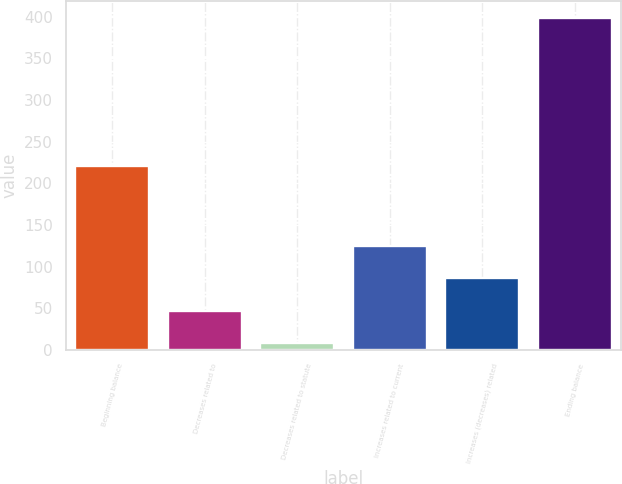Convert chart. <chart><loc_0><loc_0><loc_500><loc_500><bar_chart><fcel>Beginning balance<fcel>Decreases related to<fcel>Decreases related to statute<fcel>Increases related to current<fcel>Increases (decreases) related<fcel>Ending balance<nl><fcel>220.7<fcel>46.69<fcel>7.6<fcel>124.87<fcel>85.78<fcel>398.5<nl></chart> 